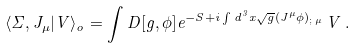<formula> <loc_0><loc_0><loc_500><loc_500>\langle \Sigma , J _ { \mu } | V \rangle _ { o } = \int D [ g , \phi ] { e ^ { - S + i \int d ^ { 3 } x \sqrt { g } ( J ^ { \mu } \phi ) _ { ; \, \mu } } } \, V \, .</formula> 